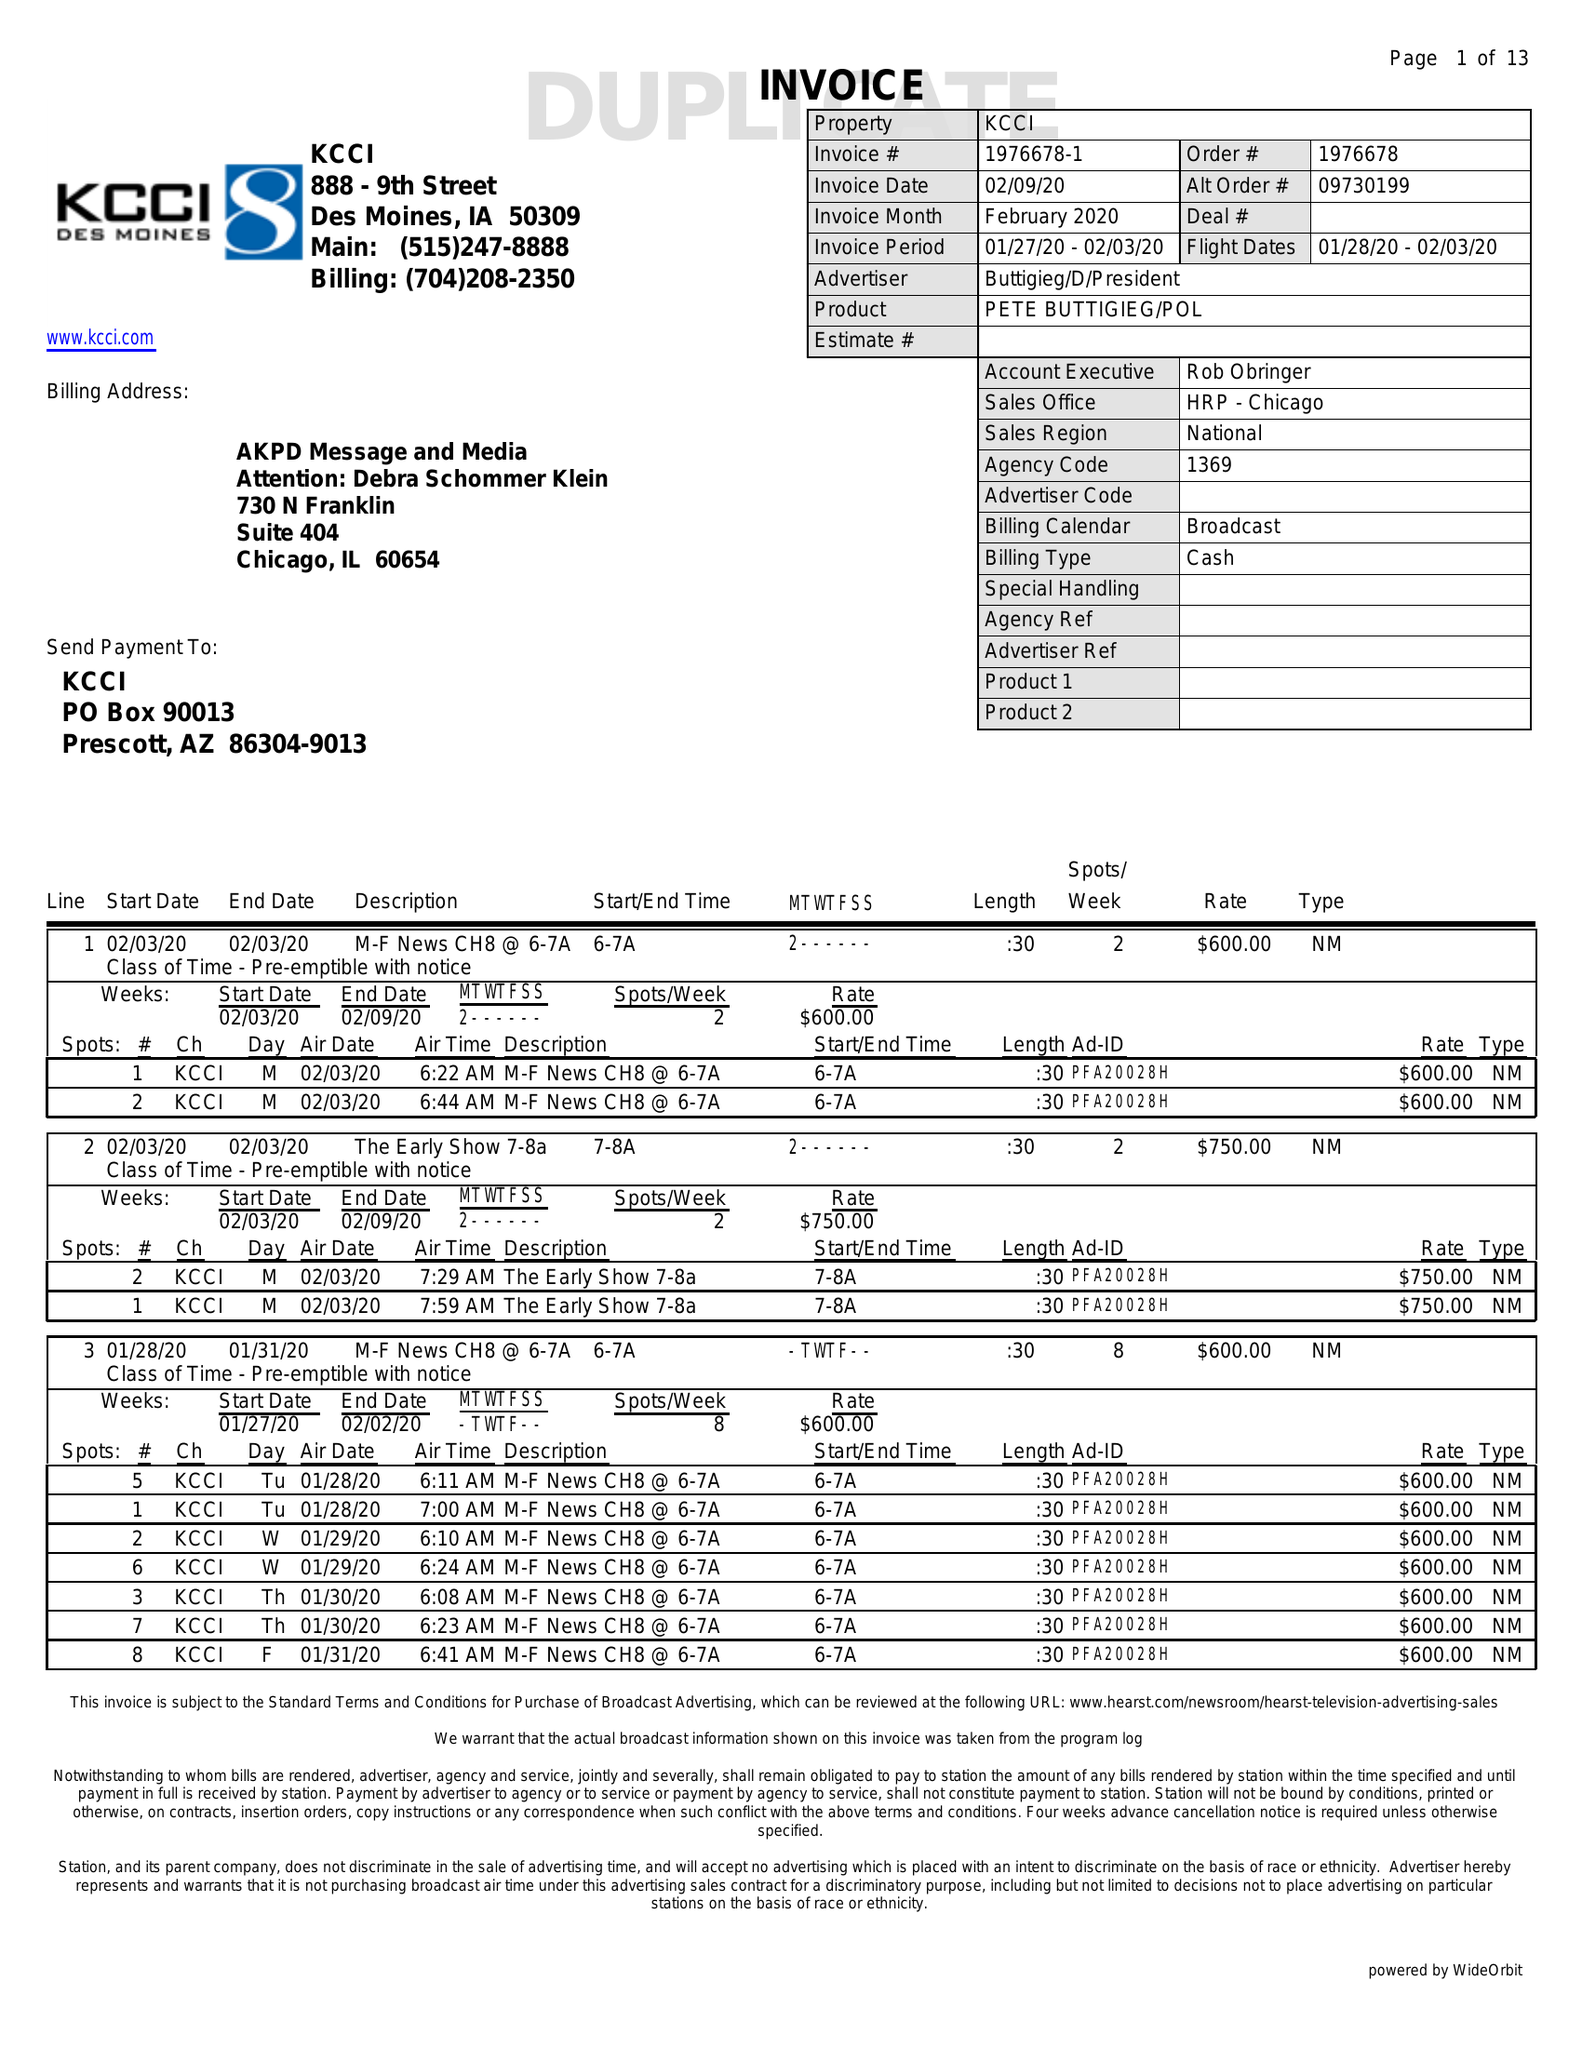What is the value for the flight_to?
Answer the question using a single word or phrase. 02/03/20 